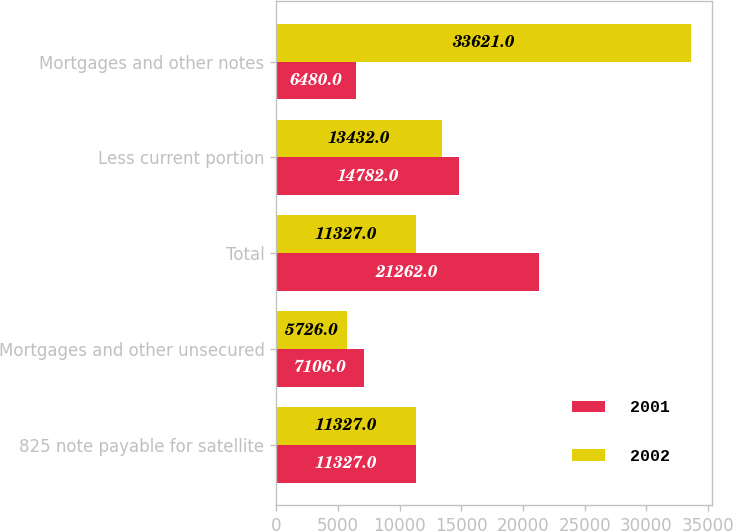Convert chart to OTSL. <chart><loc_0><loc_0><loc_500><loc_500><stacked_bar_chart><ecel><fcel>825 note payable for satellite<fcel>Mortgages and other unsecured<fcel>Total<fcel>Less current portion<fcel>Mortgages and other notes<nl><fcel>2001<fcel>11327<fcel>7106<fcel>21262<fcel>14782<fcel>6480<nl><fcel>2002<fcel>11327<fcel>5726<fcel>11327<fcel>13432<fcel>33621<nl></chart> 